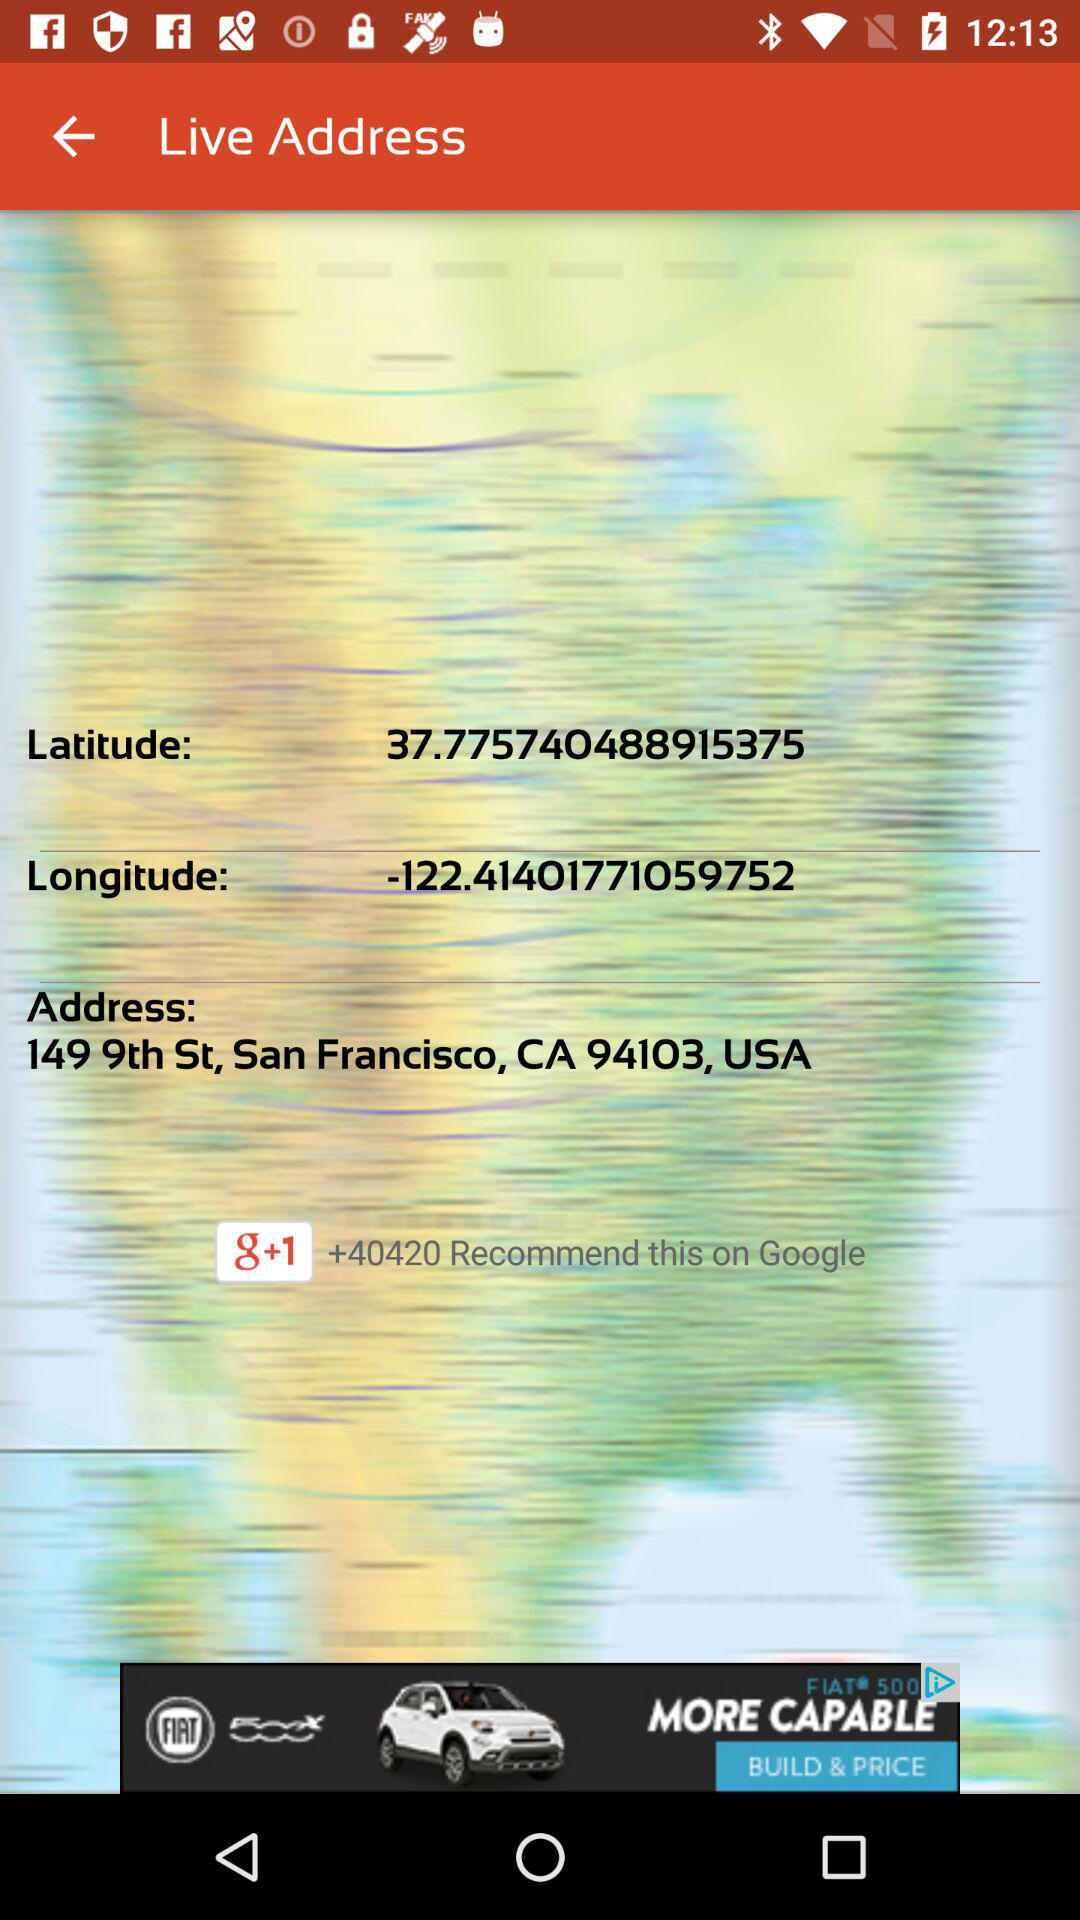What is the mentioned latitude? The mentioned latitude is 37.775740488915375. 